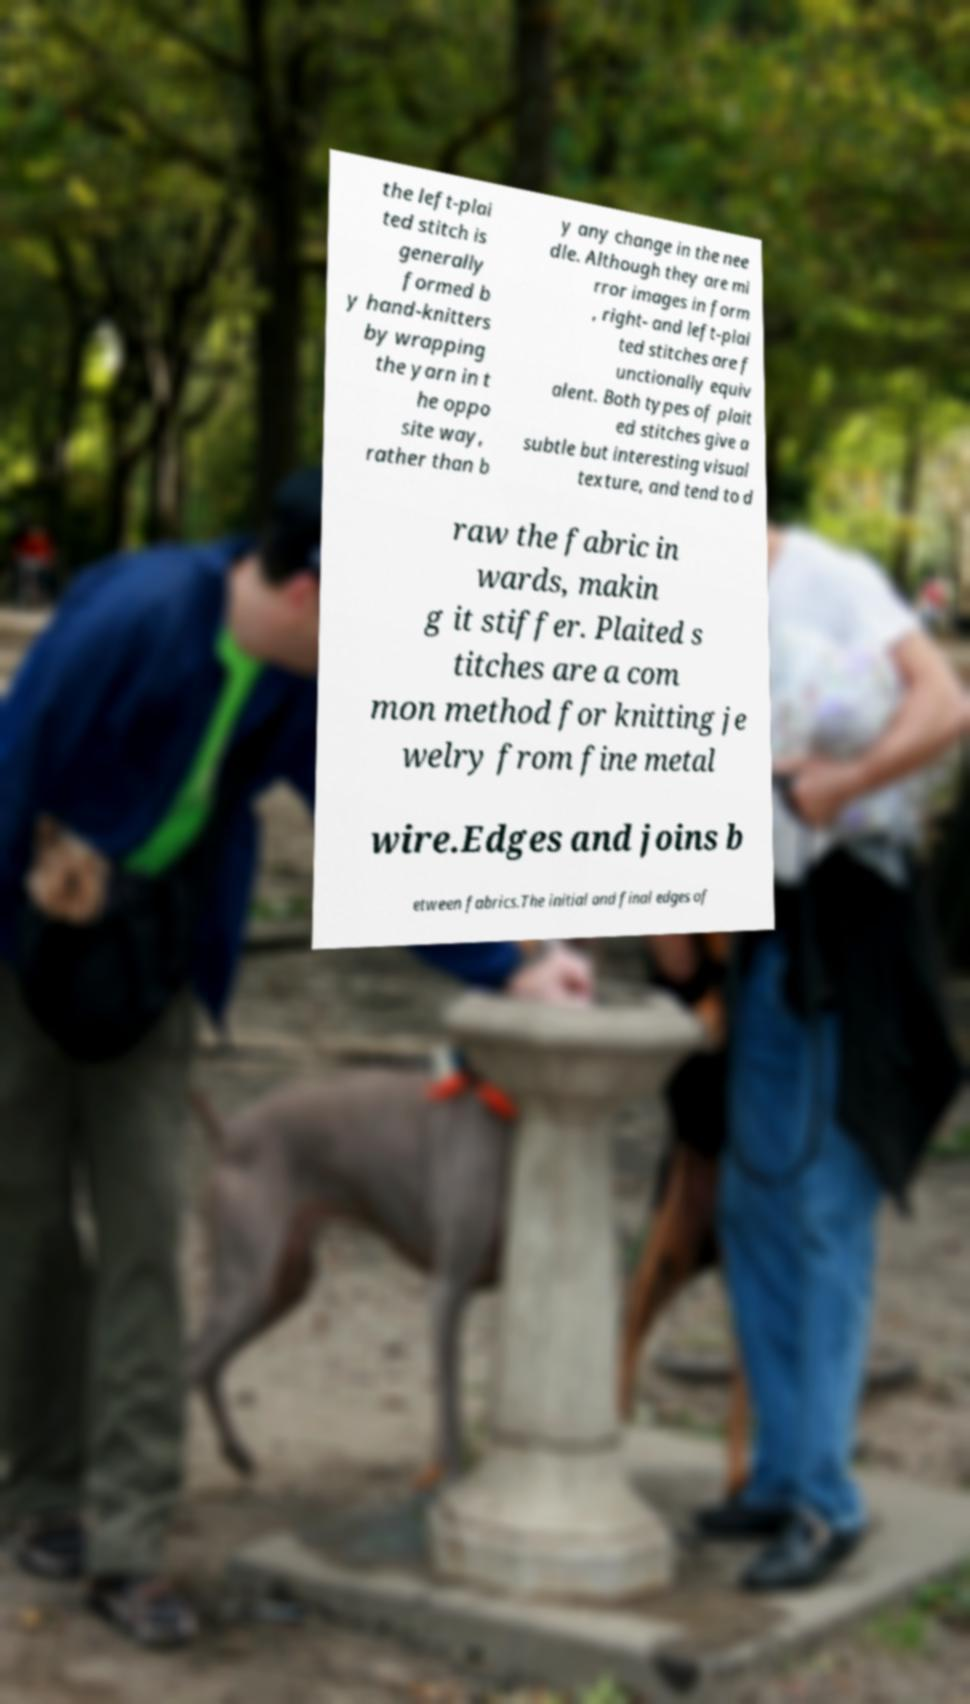What messages or text are displayed in this image? I need them in a readable, typed format. the left-plai ted stitch is generally formed b y hand-knitters by wrapping the yarn in t he oppo site way, rather than b y any change in the nee dle. Although they are mi rror images in form , right- and left-plai ted stitches are f unctionally equiv alent. Both types of plait ed stitches give a subtle but interesting visual texture, and tend to d raw the fabric in wards, makin g it stiffer. Plaited s titches are a com mon method for knitting je welry from fine metal wire.Edges and joins b etween fabrics.The initial and final edges of 